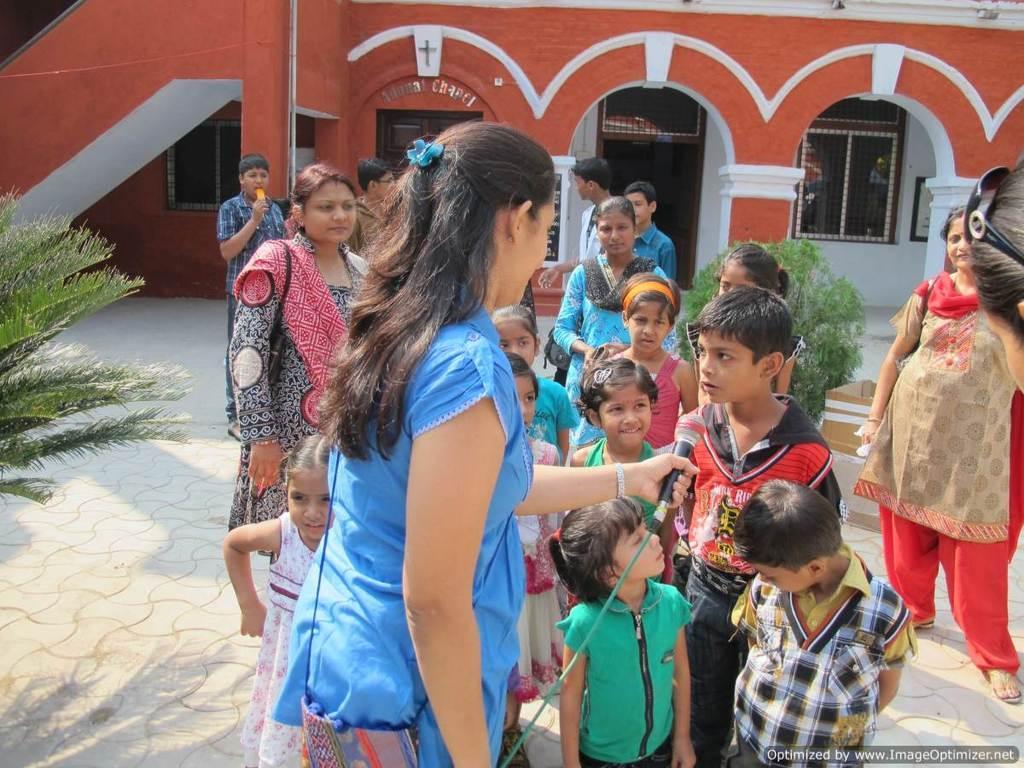In one or two sentences, can you explain what this image depicts? In this image I can see there is a woman standing at the center, she is holding a microphone and there is a boy standing in front of her and there are a few other kids. There are a few people standing in the background and there is a building and few plants. 